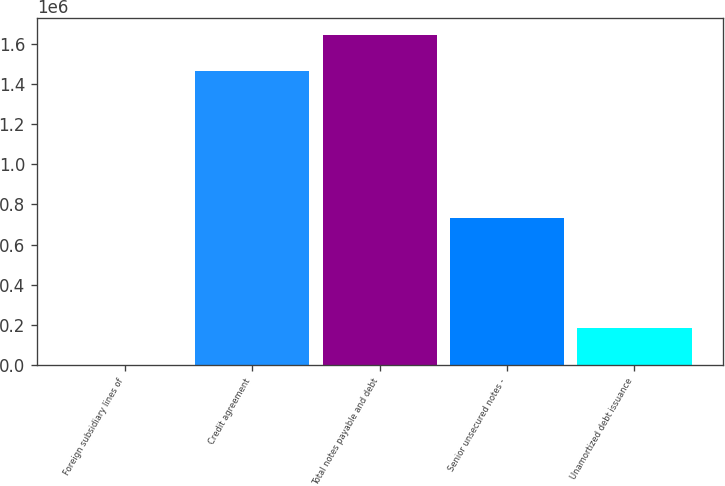Convert chart. <chart><loc_0><loc_0><loc_500><loc_500><bar_chart><fcel>Foreign subsidiary lines of<fcel>Credit agreement<fcel>Total notes payable and debt<fcel>Senior unsecured notes -<fcel>Unamortized debt issuance<nl><fcel>297<fcel>1.46187e+06<fcel>1.64457e+06<fcel>731083<fcel>182994<nl></chart> 